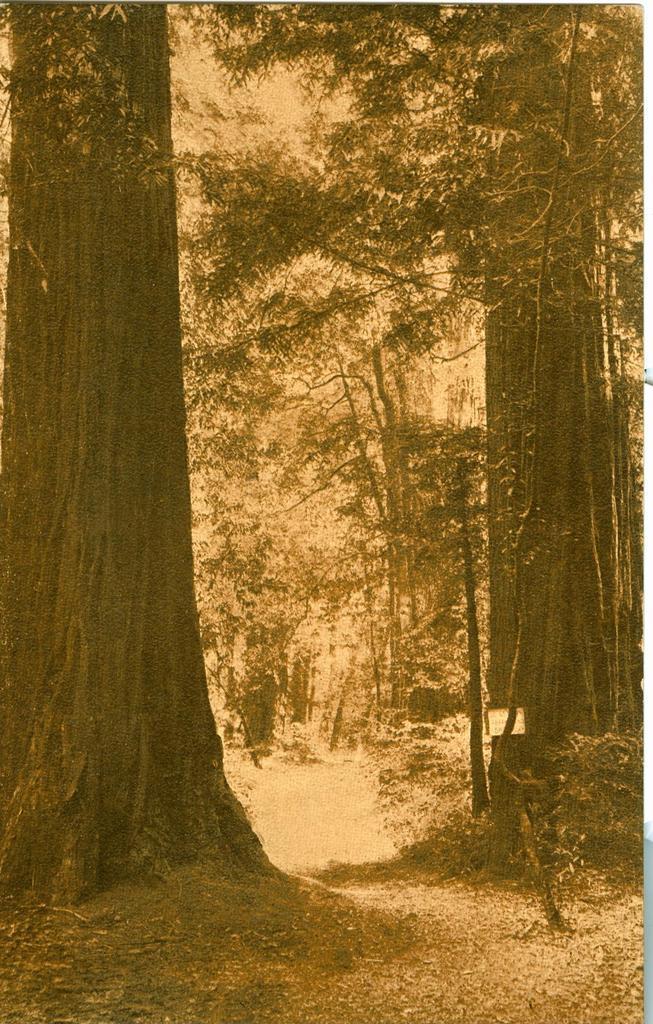In one or two sentences, can you explain what this image depicts? This is an edited image. In this image, we can see some trees and plants. At the bottom, we can see some plants and a land. 